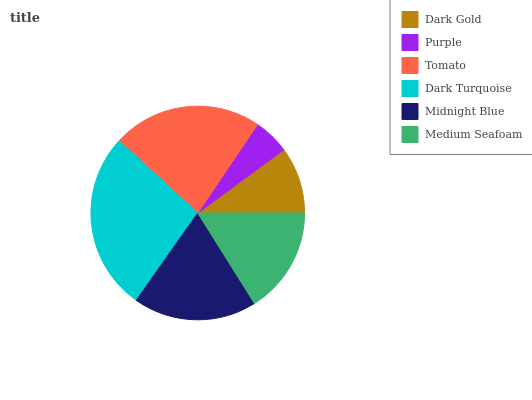Is Purple the minimum?
Answer yes or no. Yes. Is Dark Turquoise the maximum?
Answer yes or no. Yes. Is Tomato the minimum?
Answer yes or no. No. Is Tomato the maximum?
Answer yes or no. No. Is Tomato greater than Purple?
Answer yes or no. Yes. Is Purple less than Tomato?
Answer yes or no. Yes. Is Purple greater than Tomato?
Answer yes or no. No. Is Tomato less than Purple?
Answer yes or no. No. Is Midnight Blue the high median?
Answer yes or no. Yes. Is Medium Seafoam the low median?
Answer yes or no. Yes. Is Dark Turquoise the high median?
Answer yes or no. No. Is Midnight Blue the low median?
Answer yes or no. No. 